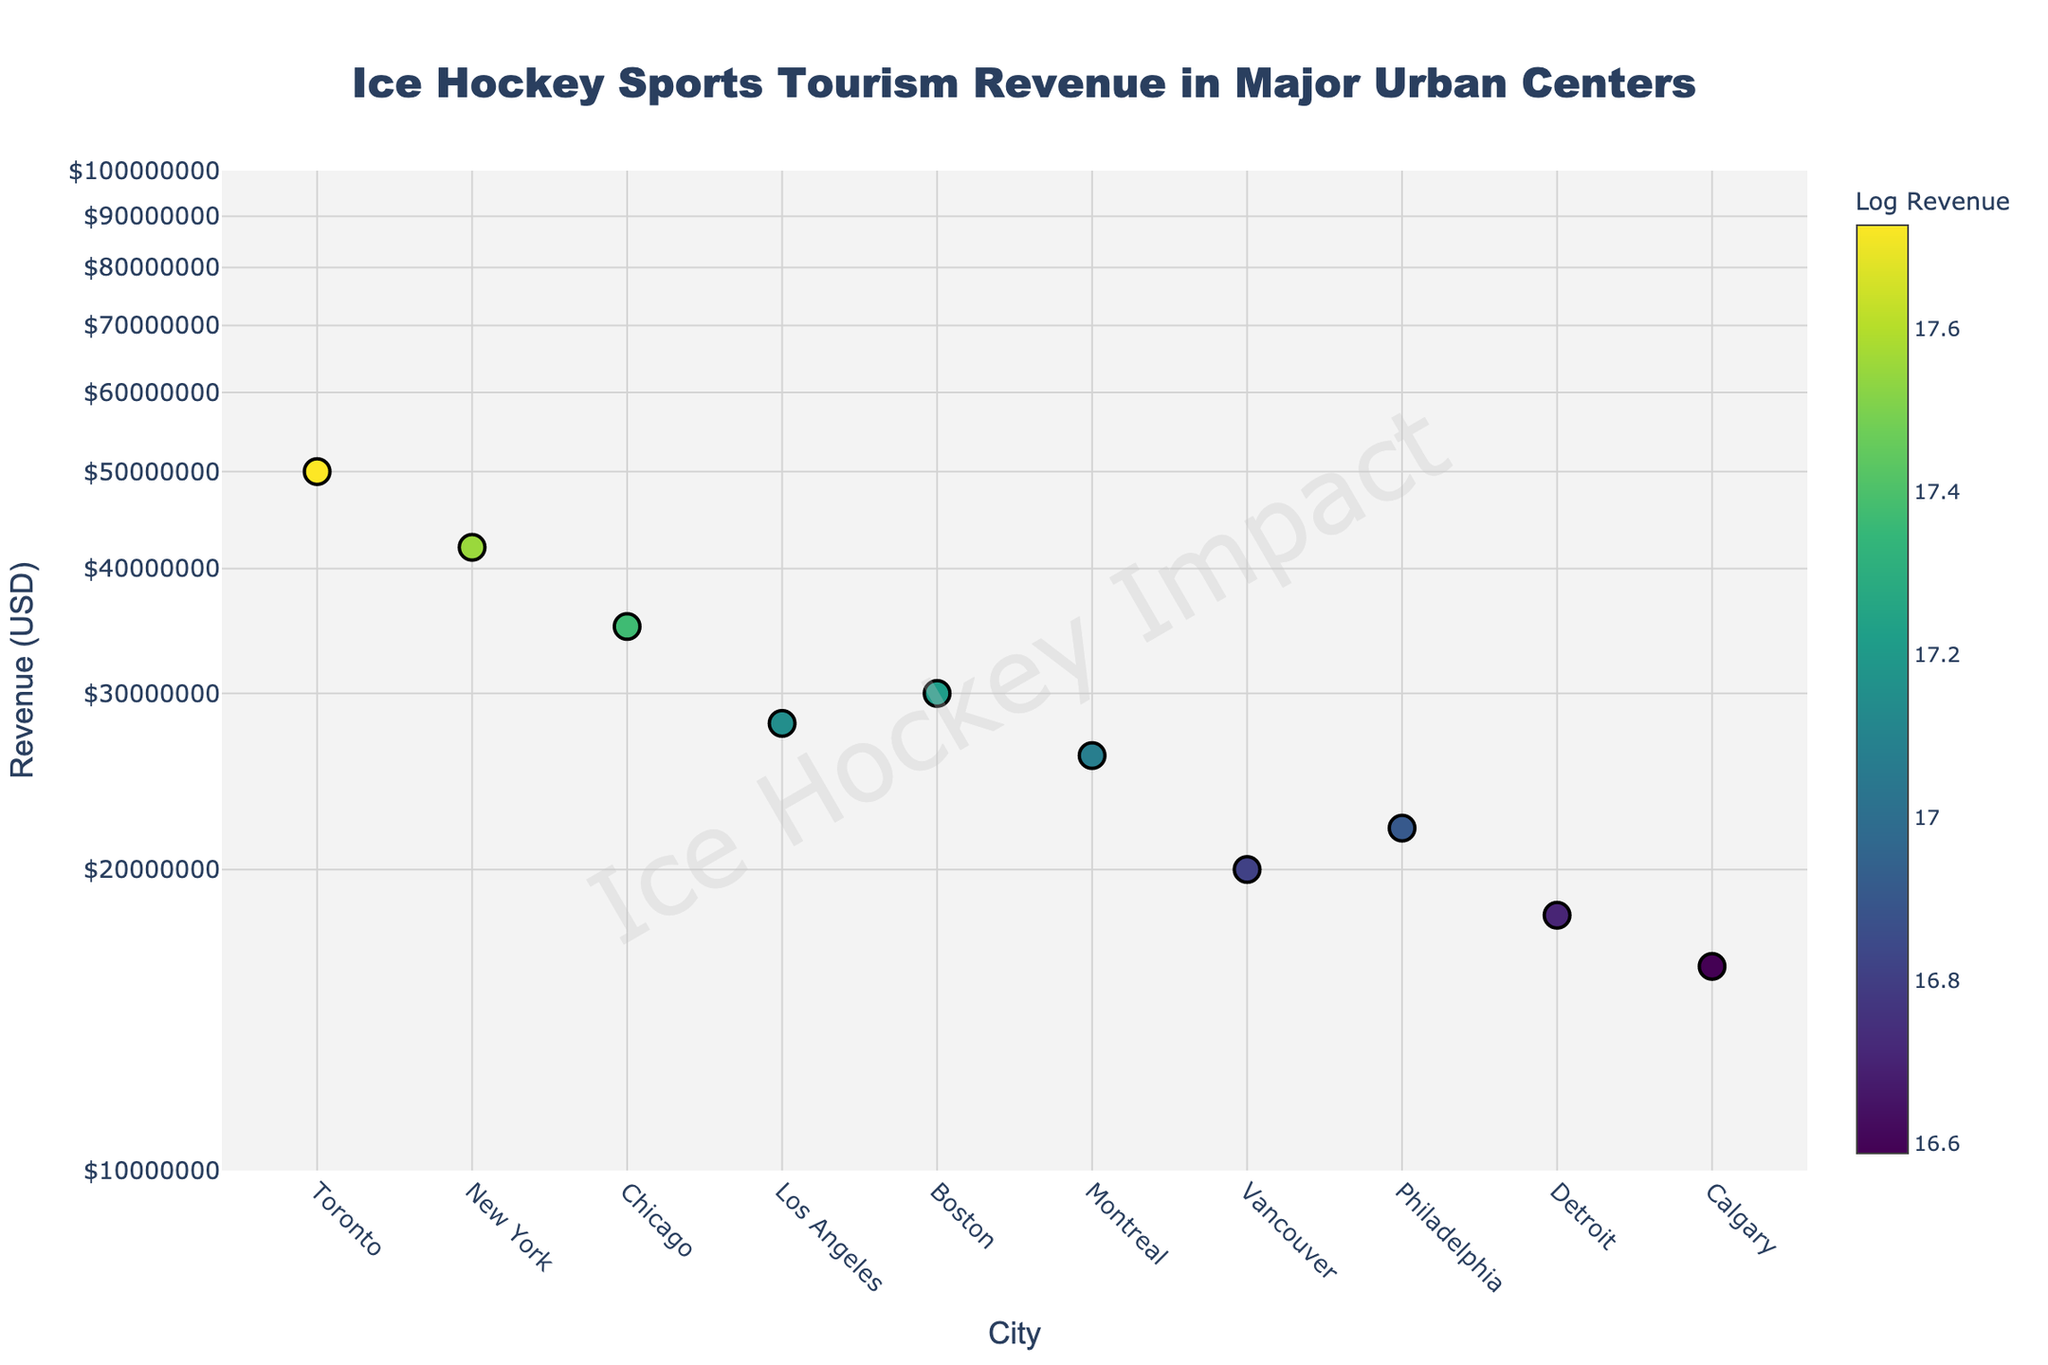how many cities are displayed in the plot? Count the number of distinct markers on the plot. Each marker represents a city.
Answer: 10 What is the total sports tourism revenue generated by the cities displayed? Sum the revenues of all cities: Toronto (50M) + New York (42M) + Chicago (35M) + Los Angeles (28M) + Boston (30M) + Montreal (26M) + Vancouver (20M) + Philadelphia (22M) + Detroit (18M) + Calgary (16M). Total = 287M USD
Answer: 287M USD Which city has the highest revenue from sports tourism related to ice hockey? Look for the city with the marker placed at the highest position on the y-axis. The city with the highest revenue of 50M USD is Toronto.
Answer: Toronto Which city has the lowest revenue from sports tourism related to ice hockey? Look for the city with the marker placed at the lowest position on the y-axis. The city with the lowest revenue of 16M USD is Calgary.
Answer: Calgary How does the revenue of Boston compare to that of Montreal? Compare the y-axis positions for Boston with revenue of 30M USD and Montreal with revenue of 26M USD. Boston's marker is higher.
Answer: Boston's revenue is higher What is the approximate difference in revenue between New York and Chicago? Subtract Chicago's revenue of 35M USD from New York's 42M USD. Difference = 42M - 35M = 7M USD
Answer: 7M USD Rank the cities based on their revenue from highest to lowest. Arrange the cities in descending order according to their y-axis positions representing their revenues. Toronto (50M), New York (42M), Chicago (35M), Boston (30M), Los Angeles (28M), Montreal (26M), Philadelphia (22M), Vancouver (20M), Detroit (18M), Calgary (16M).
Answer: Toronto, New York, Chicago, Boston, Los Angeles, Montreal, Philadelphia, Vancouver, Detroit, Calgary What is the median revenue of the cities displayed? Order the cities by revenue and find the middle value. The middle values of the ordered list (16M, 18M, 20M, 22M, 26M, 28M, 30M, 35M, 42M, 50M) are 26M and 28M. Median = (26M + 28M) / 2 = 27M USD.
Answer: 27M USD What is the revenue of the city closest to the average value? Calculate the average revenue: Total revenue (287M) / 10 cities = 28.7M USD. Identify the city with revenue closest to the average. Los Angeles has a revenue of 28M USD.
Answer: Los Angeles How is the color of the markers related to revenue? Observing the colors and their tones, brighter markers indicate higher revenue (based on log scaling) while darker markers indicate lower revenue.
Answer: Higher revenue sports centers have brighter markers 